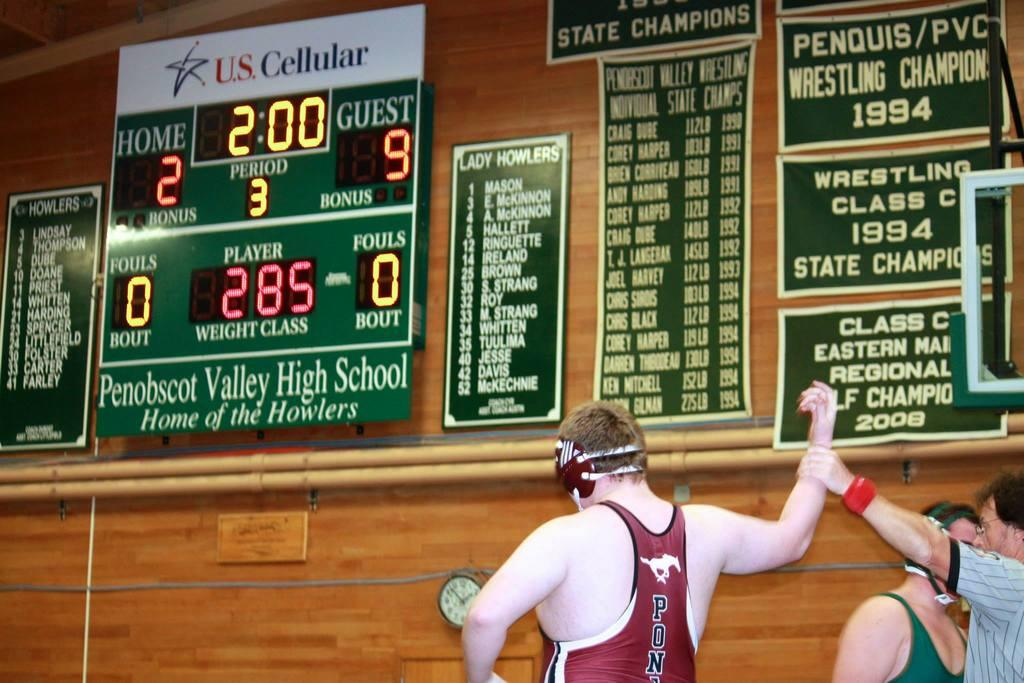<image>
Render a clear and concise summary of the photo. a wrestler that is near an ad with US cellular on it 